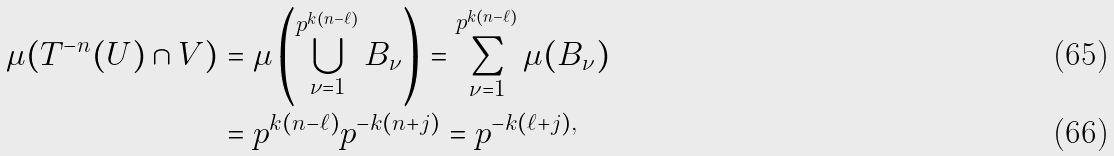Convert formula to latex. <formula><loc_0><loc_0><loc_500><loc_500>\mu ( T ^ { - n } ( U ) \cap V ) & = \mu \left ( \bigcup _ { \nu = 1 } ^ { p ^ { k ( n - \ell ) } } B _ { \nu } \right ) = \sum _ { \nu = 1 } ^ { p ^ { k ( n - \ell ) } } \mu ( B _ { \nu } ) \\ & = p ^ { k ( n - \ell ) } p ^ { - k ( n + j ) } = p ^ { - k ( \ell + j ) , }</formula> 